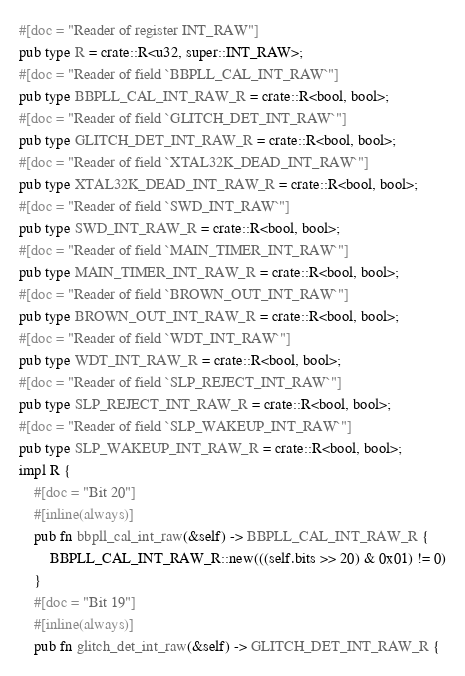<code> <loc_0><loc_0><loc_500><loc_500><_Rust_>#[doc = "Reader of register INT_RAW"]
pub type R = crate::R<u32, super::INT_RAW>;
#[doc = "Reader of field `BBPLL_CAL_INT_RAW`"]
pub type BBPLL_CAL_INT_RAW_R = crate::R<bool, bool>;
#[doc = "Reader of field `GLITCH_DET_INT_RAW`"]
pub type GLITCH_DET_INT_RAW_R = crate::R<bool, bool>;
#[doc = "Reader of field `XTAL32K_DEAD_INT_RAW`"]
pub type XTAL32K_DEAD_INT_RAW_R = crate::R<bool, bool>;
#[doc = "Reader of field `SWD_INT_RAW`"]
pub type SWD_INT_RAW_R = crate::R<bool, bool>;
#[doc = "Reader of field `MAIN_TIMER_INT_RAW`"]
pub type MAIN_TIMER_INT_RAW_R = crate::R<bool, bool>;
#[doc = "Reader of field `BROWN_OUT_INT_RAW`"]
pub type BROWN_OUT_INT_RAW_R = crate::R<bool, bool>;
#[doc = "Reader of field `WDT_INT_RAW`"]
pub type WDT_INT_RAW_R = crate::R<bool, bool>;
#[doc = "Reader of field `SLP_REJECT_INT_RAW`"]
pub type SLP_REJECT_INT_RAW_R = crate::R<bool, bool>;
#[doc = "Reader of field `SLP_WAKEUP_INT_RAW`"]
pub type SLP_WAKEUP_INT_RAW_R = crate::R<bool, bool>;
impl R {
    #[doc = "Bit 20"]
    #[inline(always)]
    pub fn bbpll_cal_int_raw(&self) -> BBPLL_CAL_INT_RAW_R {
        BBPLL_CAL_INT_RAW_R::new(((self.bits >> 20) & 0x01) != 0)
    }
    #[doc = "Bit 19"]
    #[inline(always)]
    pub fn glitch_det_int_raw(&self) -> GLITCH_DET_INT_RAW_R {</code> 